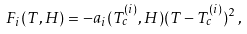Convert formula to latex. <formula><loc_0><loc_0><loc_500><loc_500>F _ { i } ( T , H ) = - a _ { i } ( T _ { c } ^ { ( i ) } , H ) ( T - T _ { c } ^ { ( i ) } ) ^ { 2 } \, ,</formula> 